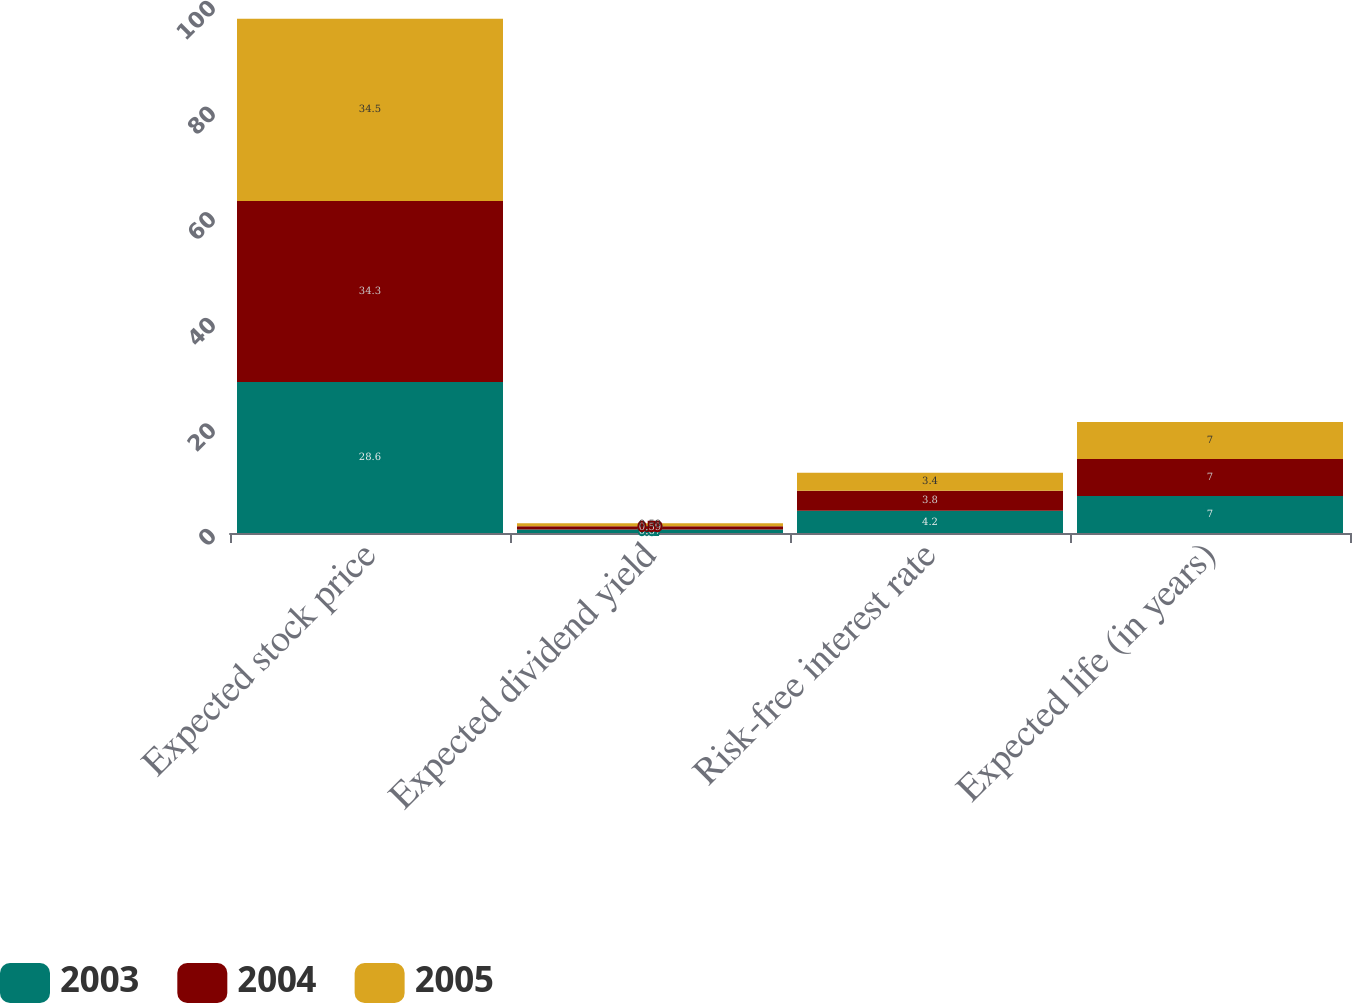Convert chart. <chart><loc_0><loc_0><loc_500><loc_500><stacked_bar_chart><ecel><fcel>Expected stock price<fcel>Expected dividend yield<fcel>Risk-free interest rate<fcel>Expected life (in years)<nl><fcel>2003<fcel>28.6<fcel>0.67<fcel>4.2<fcel>7<nl><fcel>2004<fcel>34.3<fcel>0.59<fcel>3.8<fcel>7<nl><fcel>2005<fcel>34.5<fcel>0.59<fcel>3.4<fcel>7<nl></chart> 